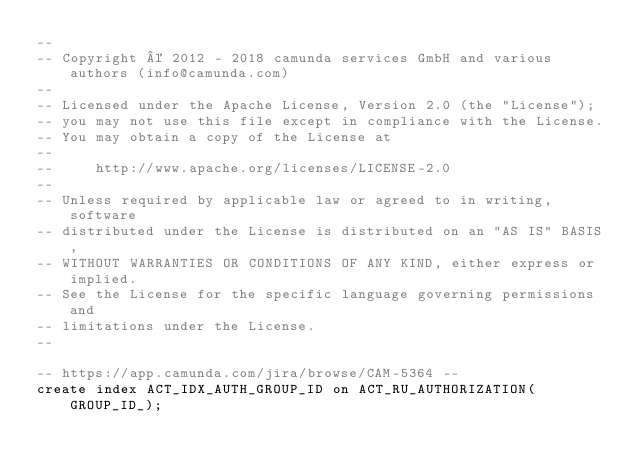<code> <loc_0><loc_0><loc_500><loc_500><_SQL_>--
-- Copyright © 2012 - 2018 camunda services GmbH and various authors (info@camunda.com)
--
-- Licensed under the Apache License, Version 2.0 (the "License");
-- you may not use this file except in compliance with the License.
-- You may obtain a copy of the License at
--
--     http://www.apache.org/licenses/LICENSE-2.0
--
-- Unless required by applicable law or agreed to in writing, software
-- distributed under the License is distributed on an "AS IS" BASIS,
-- WITHOUT WARRANTIES OR CONDITIONS OF ANY KIND, either express or implied.
-- See the License for the specific language governing permissions and
-- limitations under the License.
--

-- https://app.camunda.com/jira/browse/CAM-5364 --
create index ACT_IDX_AUTH_GROUP_ID on ACT_RU_AUTHORIZATION(GROUP_ID_);
</code> 